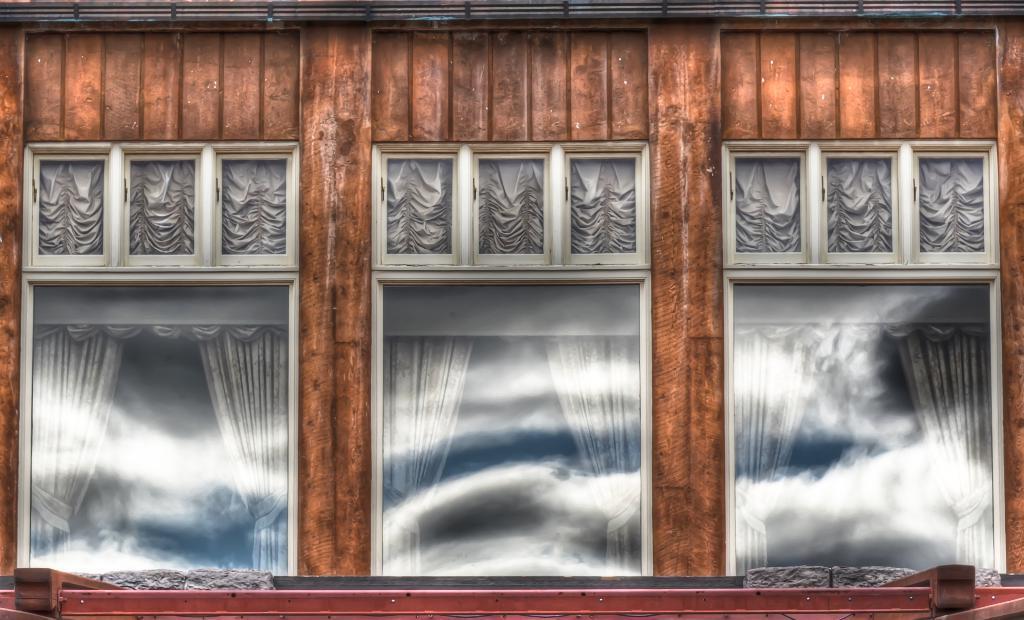In one or two sentences, can you explain what this image depicts? In this image I can see a building wall, windows and curtains. This image is taken may be during a day. 